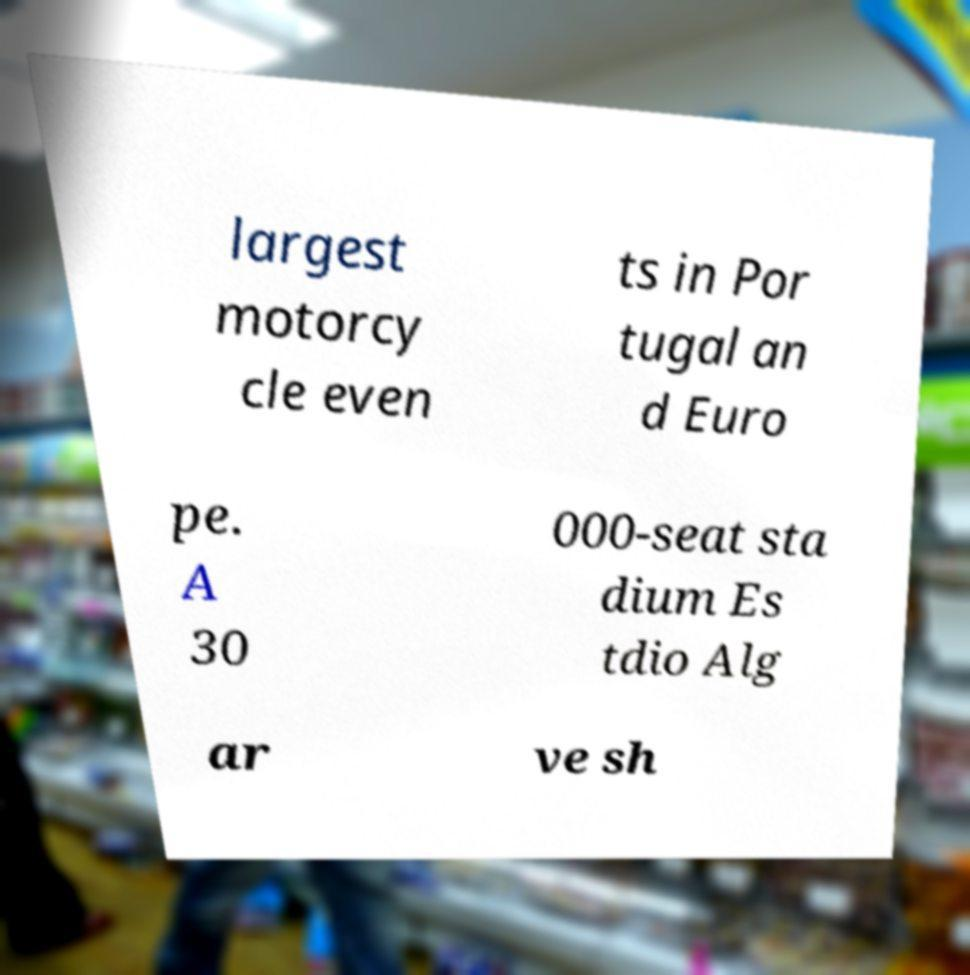There's text embedded in this image that I need extracted. Can you transcribe it verbatim? largest motorcy cle even ts in Por tugal an d Euro pe. A 30 000-seat sta dium Es tdio Alg ar ve sh 